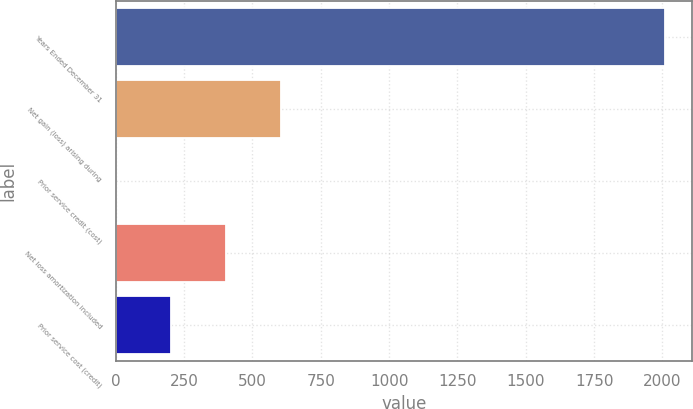<chart> <loc_0><loc_0><loc_500><loc_500><bar_chart><fcel>Years Ended December 31<fcel>Net gain (loss) arising during<fcel>Prior service credit (cost)<fcel>Net loss amortization included<fcel>Prior service cost (credit)<nl><fcel>2009<fcel>603.4<fcel>1<fcel>402.6<fcel>201.8<nl></chart> 